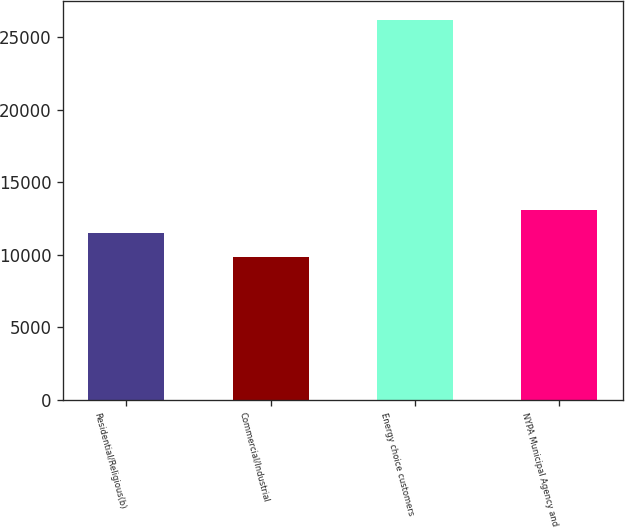Convert chart. <chart><loc_0><loc_0><loc_500><loc_500><bar_chart><fcel>Residential/Religious(b)<fcel>Commercial/Industrial<fcel>Energy choice customers<fcel>NYPA Municipal Agency and<nl><fcel>11472.7<fcel>9834<fcel>26221<fcel>13111.4<nl></chart> 